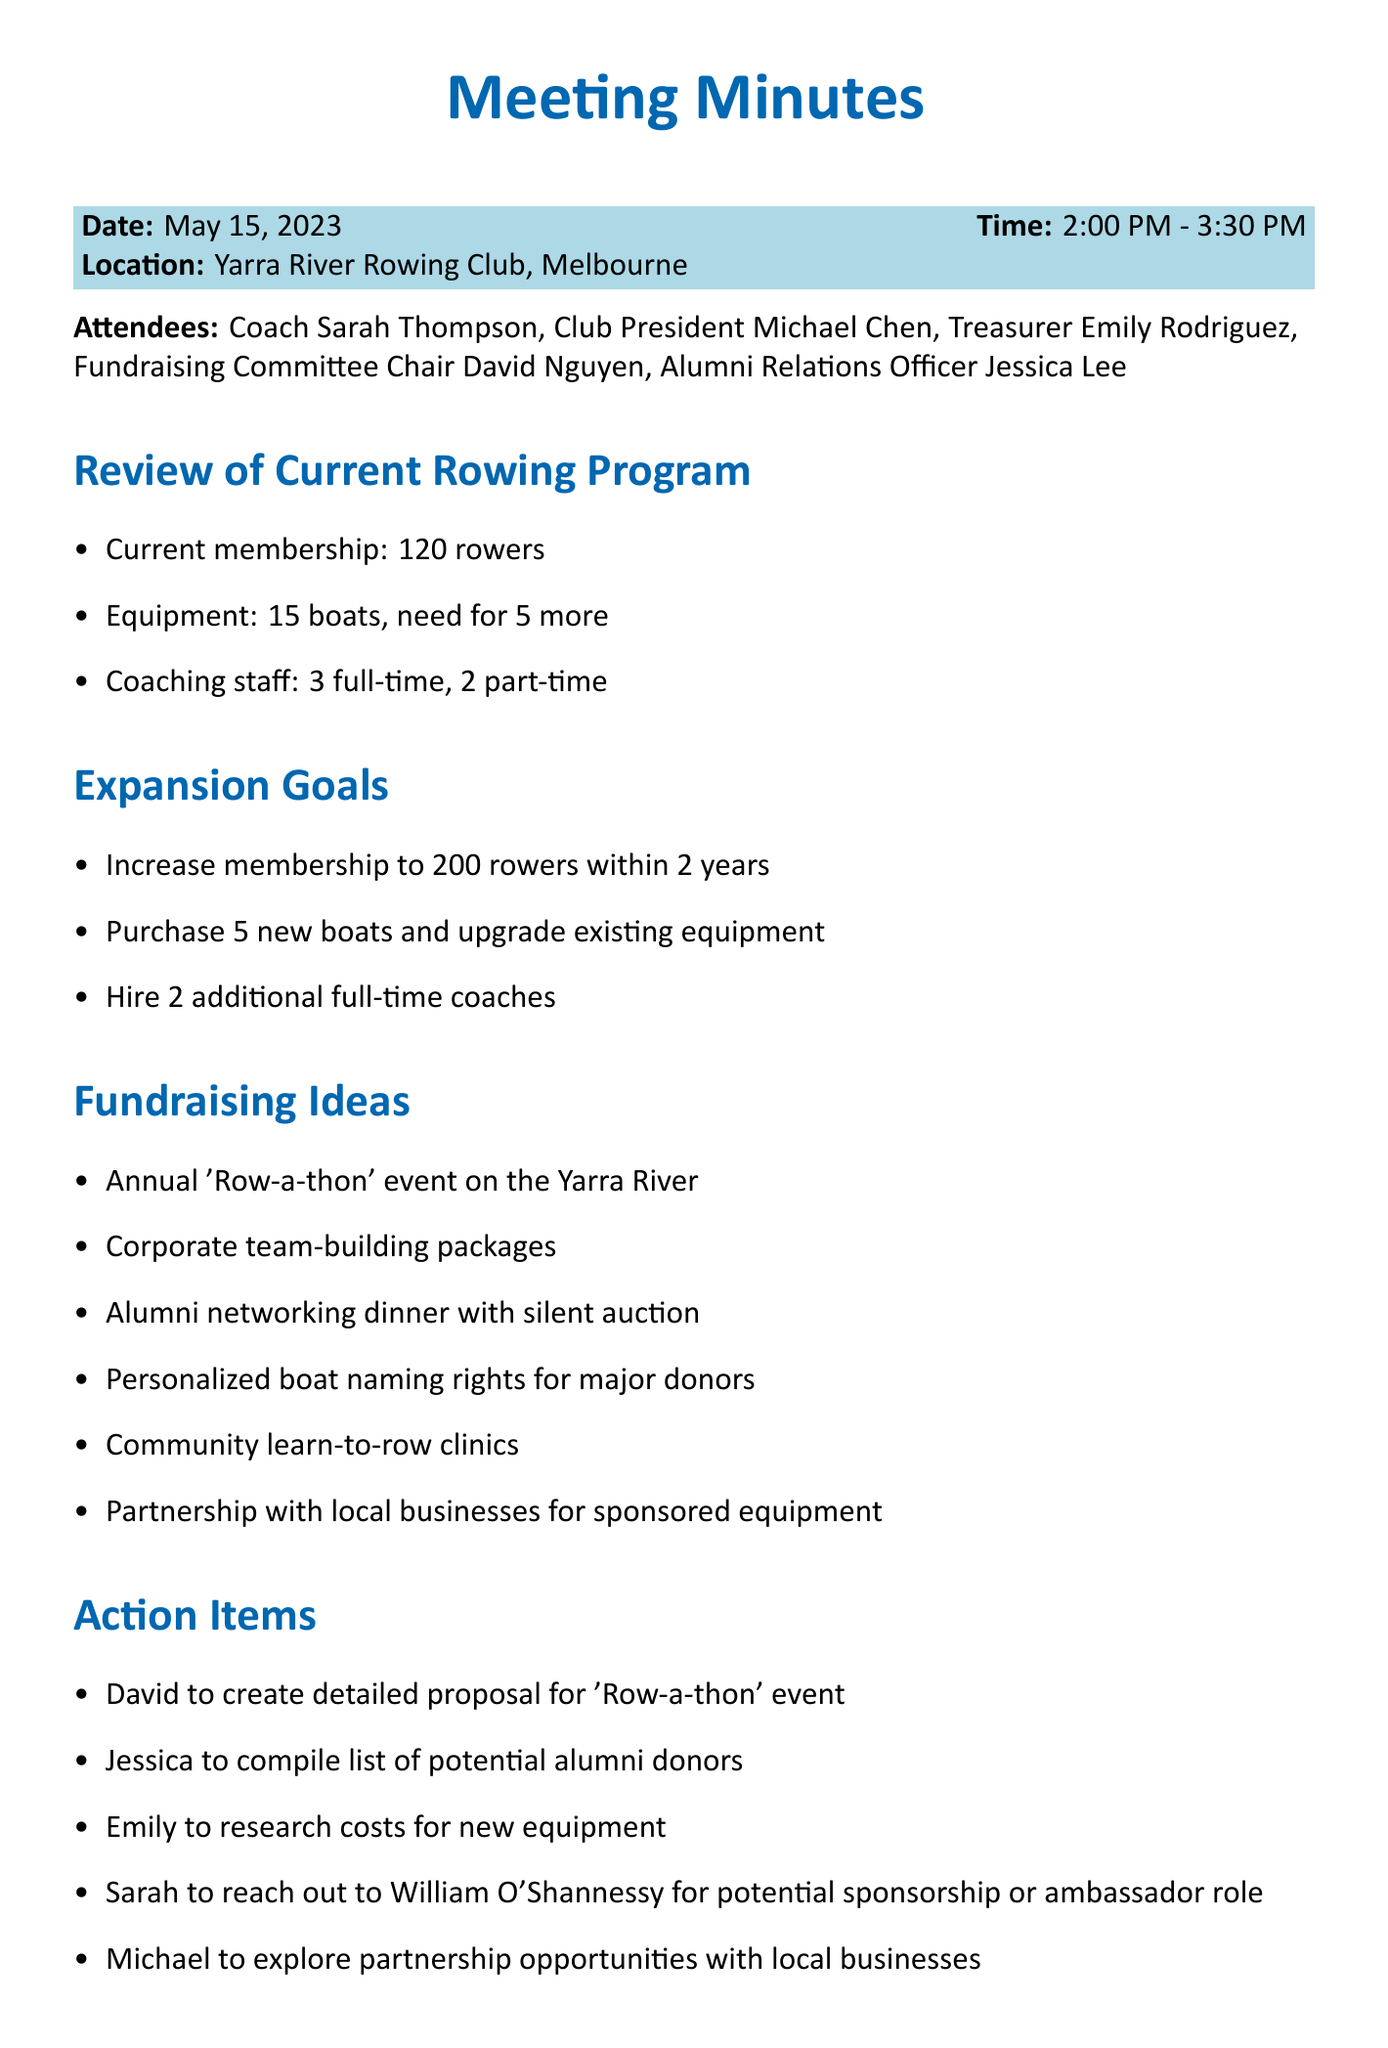What is the date of the meeting? The meeting took place on May 15, 2023.
Answer: May 15, 2023 How many attendees were present? The document lists five attendees at the meeting.
Answer: 5 What is the current membership of the rowing program? The current membership is noted as 120 rowers in the document.
Answer: 120 rowers How many new boats are needed? The need for additional boats is specified as five in the context of equipment requirements.
Answer: 5 What fundraising event is being proposed? The document suggests an annual 'Row-a-thon' event as a fundraising initiative.
Answer: 'Row-a-thon' Who is responsible for compiling the list of potential alumni donors? The action item specifies Jessica as responsible for this task.
Answer: Jessica When is the follow-up meeting scheduled? The next meeting is set for June 1, 2023.
Answer: June 1, 2023 What is the goal for rowing membership in two years? The expansion goal aims to increase membership to 200 rowers within two years.
Answer: 200 rowers What should be researched by Emily? Emily is tasked with researching costs for new equipment as noted in the action items.
Answer: Costs for new equipment 